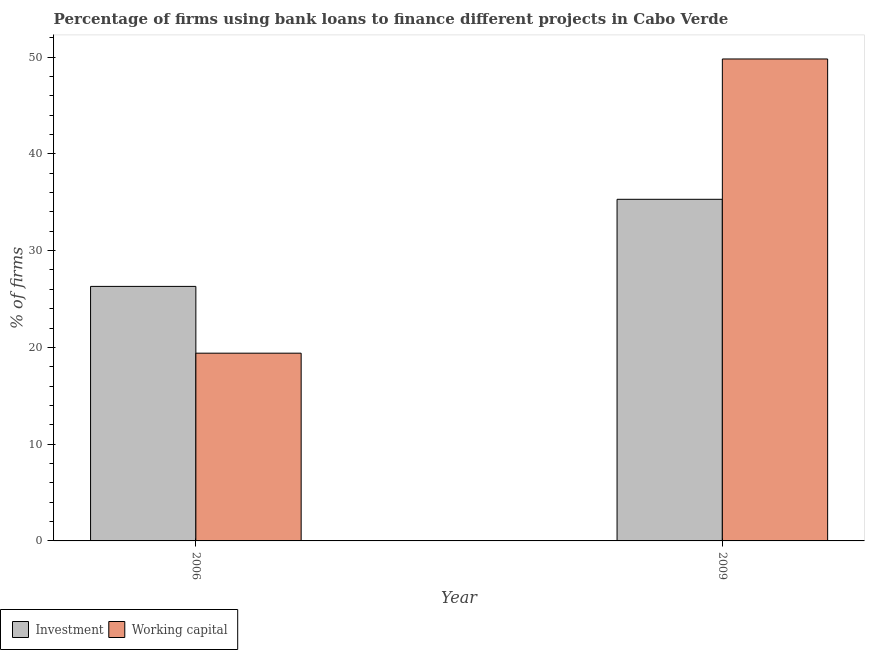How many groups of bars are there?
Offer a very short reply. 2. Are the number of bars per tick equal to the number of legend labels?
Give a very brief answer. Yes. Are the number of bars on each tick of the X-axis equal?
Provide a short and direct response. Yes. What is the label of the 2nd group of bars from the left?
Offer a very short reply. 2009. In how many cases, is the number of bars for a given year not equal to the number of legend labels?
Offer a very short reply. 0. What is the percentage of firms using banks to finance investment in 2006?
Make the answer very short. 26.3. Across all years, what is the maximum percentage of firms using banks to finance working capital?
Your answer should be compact. 49.8. Across all years, what is the minimum percentage of firms using banks to finance working capital?
Your answer should be compact. 19.4. In which year was the percentage of firms using banks to finance investment minimum?
Your answer should be very brief. 2006. What is the total percentage of firms using banks to finance working capital in the graph?
Ensure brevity in your answer.  69.2. What is the difference between the percentage of firms using banks to finance working capital in 2006 and that in 2009?
Offer a very short reply. -30.4. What is the difference between the percentage of firms using banks to finance working capital in 2009 and the percentage of firms using banks to finance investment in 2006?
Your answer should be compact. 30.4. What is the average percentage of firms using banks to finance working capital per year?
Ensure brevity in your answer.  34.6. In the year 2006, what is the difference between the percentage of firms using banks to finance working capital and percentage of firms using banks to finance investment?
Make the answer very short. 0. In how many years, is the percentage of firms using banks to finance investment greater than 12 %?
Provide a succinct answer. 2. What is the ratio of the percentage of firms using banks to finance investment in 2006 to that in 2009?
Offer a terse response. 0.75. In how many years, is the percentage of firms using banks to finance investment greater than the average percentage of firms using banks to finance investment taken over all years?
Offer a terse response. 1. What does the 1st bar from the left in 2009 represents?
Provide a succinct answer. Investment. What does the 1st bar from the right in 2006 represents?
Provide a succinct answer. Working capital. Are all the bars in the graph horizontal?
Your response must be concise. No. Are the values on the major ticks of Y-axis written in scientific E-notation?
Ensure brevity in your answer.  No. Does the graph contain grids?
Your answer should be very brief. No. How many legend labels are there?
Provide a succinct answer. 2. How are the legend labels stacked?
Your answer should be compact. Horizontal. What is the title of the graph?
Make the answer very short. Percentage of firms using bank loans to finance different projects in Cabo Verde. What is the label or title of the Y-axis?
Your response must be concise. % of firms. What is the % of firms of Investment in 2006?
Offer a terse response. 26.3. What is the % of firms of Working capital in 2006?
Ensure brevity in your answer.  19.4. What is the % of firms in Investment in 2009?
Your answer should be compact. 35.3. What is the % of firms of Working capital in 2009?
Your answer should be very brief. 49.8. Across all years, what is the maximum % of firms of Investment?
Ensure brevity in your answer.  35.3. Across all years, what is the maximum % of firms of Working capital?
Your answer should be compact. 49.8. Across all years, what is the minimum % of firms of Investment?
Your answer should be very brief. 26.3. Across all years, what is the minimum % of firms of Working capital?
Offer a very short reply. 19.4. What is the total % of firms of Investment in the graph?
Your answer should be very brief. 61.6. What is the total % of firms in Working capital in the graph?
Give a very brief answer. 69.2. What is the difference between the % of firms in Investment in 2006 and that in 2009?
Offer a terse response. -9. What is the difference between the % of firms of Working capital in 2006 and that in 2009?
Offer a terse response. -30.4. What is the difference between the % of firms in Investment in 2006 and the % of firms in Working capital in 2009?
Offer a terse response. -23.5. What is the average % of firms in Investment per year?
Keep it short and to the point. 30.8. What is the average % of firms in Working capital per year?
Offer a very short reply. 34.6. In the year 2006, what is the difference between the % of firms in Investment and % of firms in Working capital?
Make the answer very short. 6.9. What is the ratio of the % of firms of Investment in 2006 to that in 2009?
Offer a very short reply. 0.74. What is the ratio of the % of firms of Working capital in 2006 to that in 2009?
Offer a very short reply. 0.39. What is the difference between the highest and the second highest % of firms of Investment?
Provide a short and direct response. 9. What is the difference between the highest and the second highest % of firms in Working capital?
Provide a short and direct response. 30.4. What is the difference between the highest and the lowest % of firms in Investment?
Your answer should be very brief. 9. What is the difference between the highest and the lowest % of firms of Working capital?
Your answer should be very brief. 30.4. 